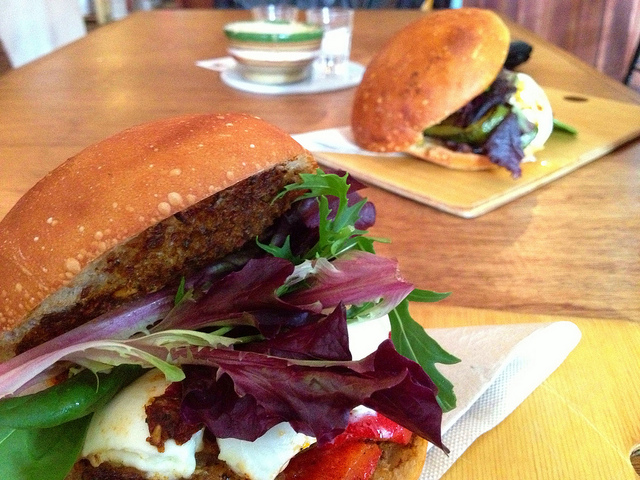How many sandwiches are in the photo? 3 